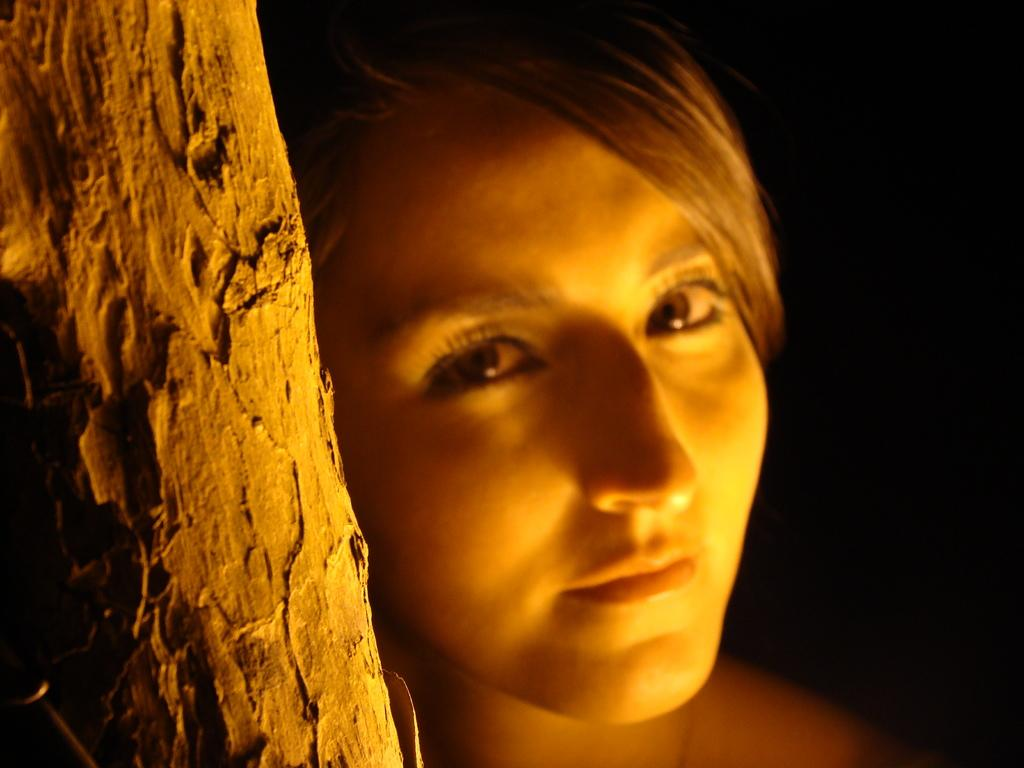Who is present in the image? There is a woman in the image. What is the woman doing in the image? The woman is standing behind a tree. What can be seen in the background of the image? The backdrop of the image is dark. What type of pipe is the woman smoking in the image? There is no pipe present in the image, and the woman is not smoking. 